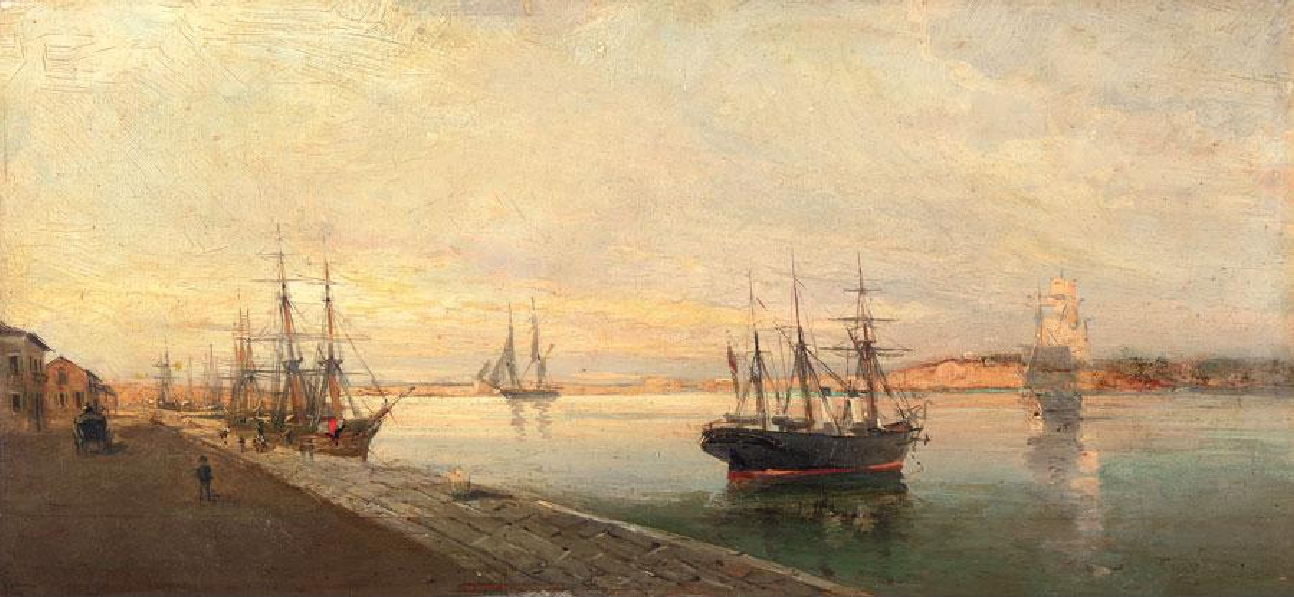If you could step into this painting, what sounds might you hear? Stepping into this painting, you might hear a symphony of harbor sounds: the gentle lapping of water against the hulls of ships, the creak of wooden masts, the distant call of seagulls, and the murmur of people going about their daily activities. You might also hear the soft clinking of tools and the occasional shout of workers as they load and unload cargo. The overall audio landscape would be a harmonious blend of natural and human-made sounds, contributing to the dynamic yet tranquil atmosphere of the harbor. 